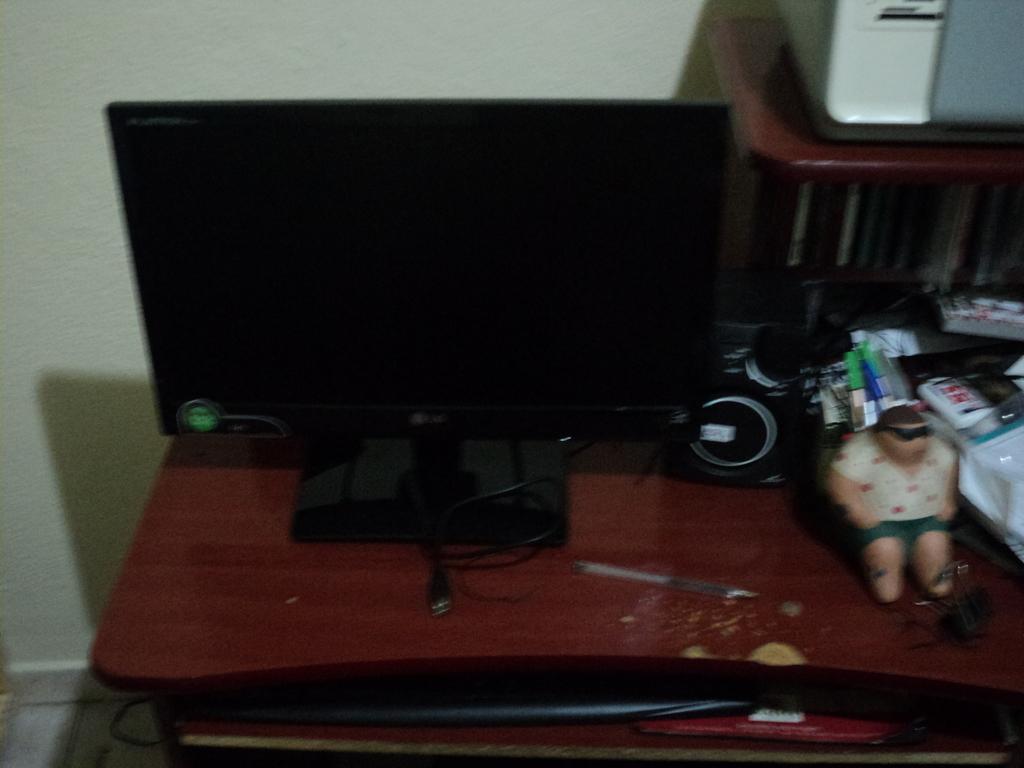Describe this image in one or two sentences. In this image there is a monitor, speaker and a few other objects are placed on top of a table, behind the table there is a wall. 